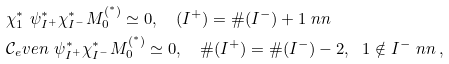<formula> <loc_0><loc_0><loc_500><loc_500>& \chi ^ { * } _ { 1 } \ \psi ^ { * } _ { I ^ { + } } \chi ^ { * } _ { I ^ { - } } M ^ { ( ^ { * } ) } _ { 0 } \simeq 0 , \quad ( I ^ { + } ) = \# ( I ^ { - } ) + 1 \ n n \\ & \mathcal { C } _ { e } v e n \ \psi ^ { * } _ { I ^ { + } } \chi ^ { * } _ { I ^ { - } } M ^ { ( ^ { * } ) } _ { 0 } \simeq 0 , \quad \# ( I ^ { + } ) = \# ( I ^ { - } ) - 2 , \ \ 1 \notin I ^ { - } \ n n \, ,</formula> 